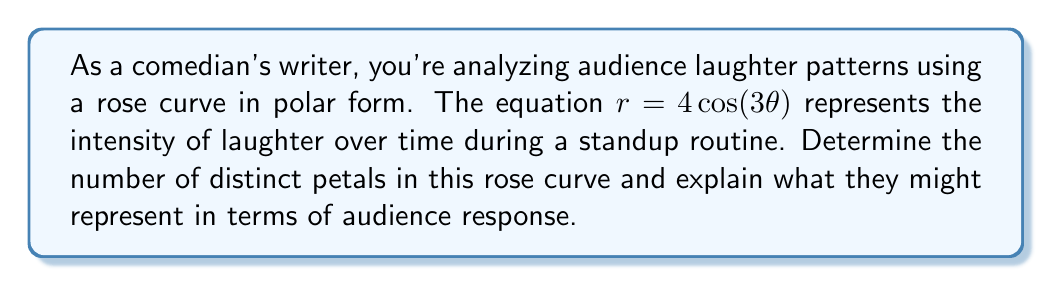Provide a solution to this math problem. To solve this problem, we need to follow these steps:

1) The general form of a rose curve is $r = a\cos(n\theta)$ or $r = a\sin(n\theta)$, where $a$ is the amplitude and $n$ is the frequency.

2) In our case, $r = 4\cos(3\theta)$, so $a = 4$ and $n = 3$.

3) The number of petals in a rose curve depends on $n$:
   - If $n$ is odd, there are $n$ petals.
   - If $n$ is even, there are $2n$ petals.

4) In this case, $n = 3$, which is odd. Therefore, the curve will have 3 petals.

5) To visualize this:

[asy]
import graph;
size(200);
real r(real t) {return 4*cos(3*t);}
draw(polargraph(r,0,2pi),blue);
draw(circle(0,4),dashed);
draw((-4,0)--(4,0),gray);
draw((0,-4)--(0,4),gray);
label("$\theta = 0$",(4,0),E);
label("$\theta = \frac{\pi}{3}$",(2,3.46),NE);
label("$\theta = \frac{2\pi}{3}$",(-2,3.46),NW);
[/asy]

6) In terms of audience response, each petal could represent a major laugh or applause break during the routine. The three petals suggest there might be three main peaks of laughter or audience engagement during the performance.

7) The symmetry of the curve indicates that these laugh patterns are evenly spaced throughout the routine, possibly corresponding to the setup, middle, and punchline of a well-structured joke or the beginning, middle, and end of the overall performance.
Answer: The rose curve $r = 4\cos(3\theta)$ has 3 distinct petals, which could represent three major peaks of laughter or audience engagement evenly distributed throughout the comedy routine. 